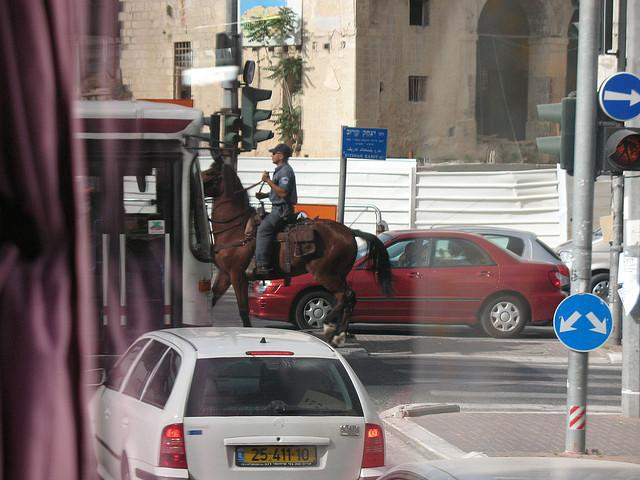What model is the red car? Please explain your reasoning. sedan. The model of the car is a sedan. 